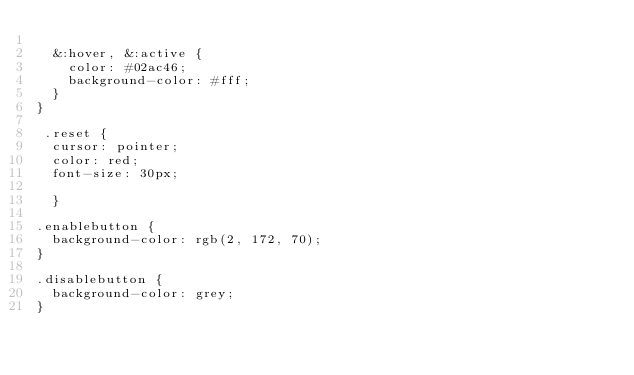<code> <loc_0><loc_0><loc_500><loc_500><_CSS_>  
  &:hover, &:active {
    color: #02ac46;
    background-color: #fff;
  }
}
  
 .reset {
  cursor: pointer;
  color: red;
  font-size: 30px;
   
  }

.enablebutton {
  background-color: rgb(2, 172, 70);
}

.disablebutton {
  background-color: grey;
}</code> 